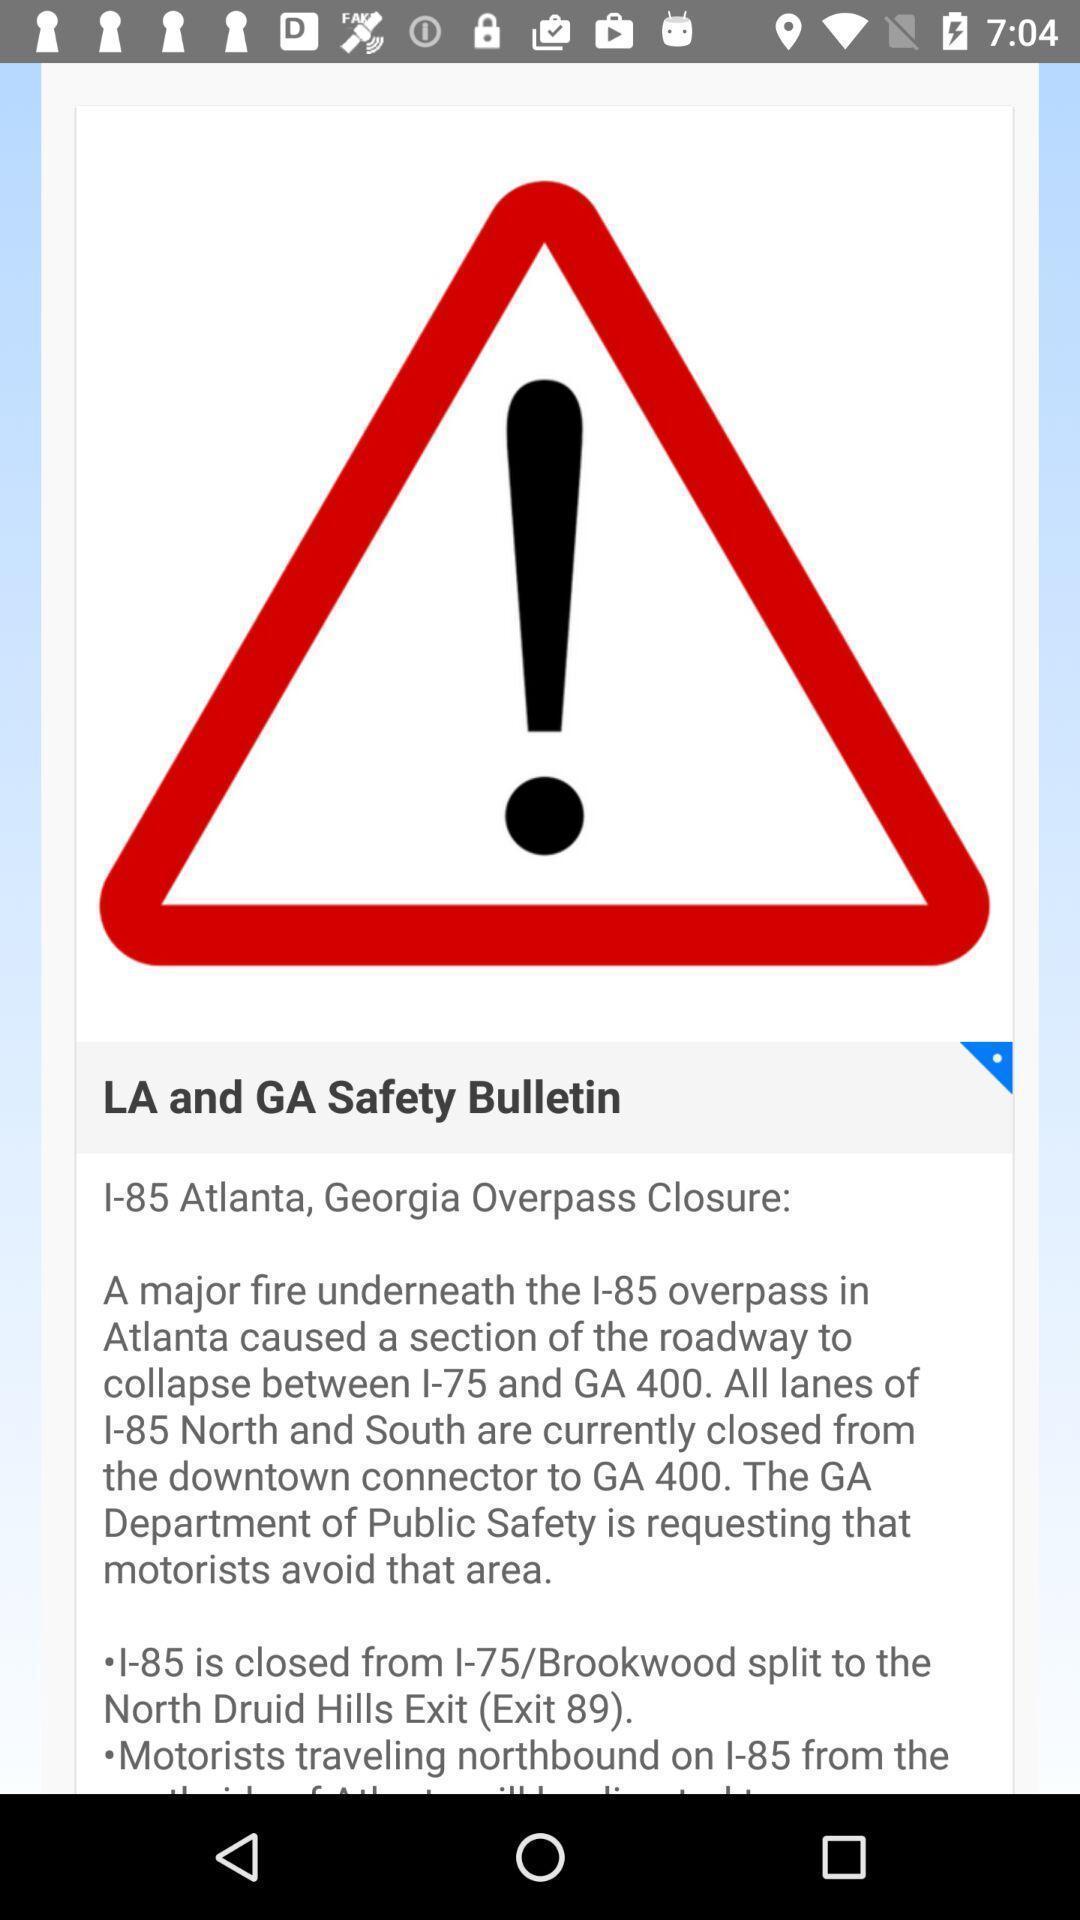Describe the key features of this screenshot. Warning page of the app. 